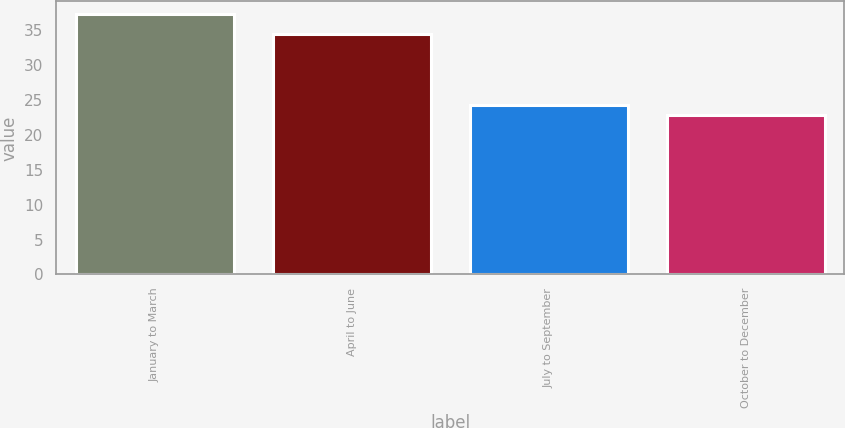Convert chart. <chart><loc_0><loc_0><loc_500><loc_500><bar_chart><fcel>January to March<fcel>April to June<fcel>July to September<fcel>October to December<nl><fcel>37.25<fcel>34.5<fcel>24.33<fcel>22.85<nl></chart> 